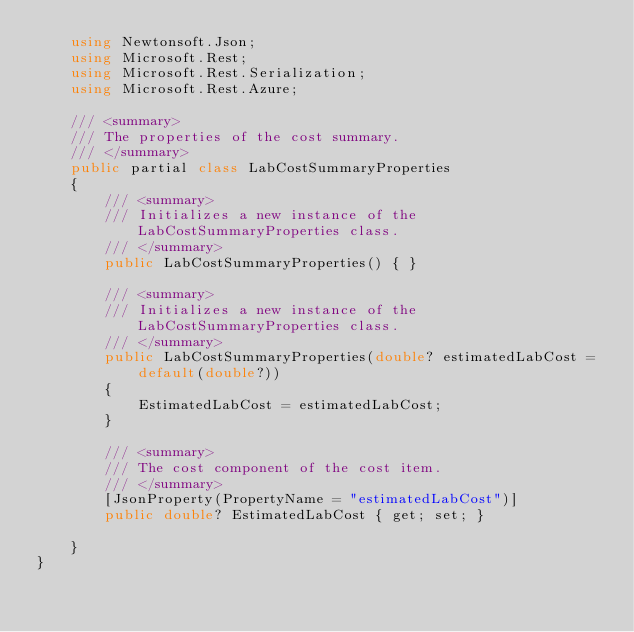<code> <loc_0><loc_0><loc_500><loc_500><_C#_>    using Newtonsoft.Json;
    using Microsoft.Rest;
    using Microsoft.Rest.Serialization;
    using Microsoft.Rest.Azure;

    /// <summary>
    /// The properties of the cost summary.
    /// </summary>
    public partial class LabCostSummaryProperties
    {
        /// <summary>
        /// Initializes a new instance of the LabCostSummaryProperties class.
        /// </summary>
        public LabCostSummaryProperties() { }

        /// <summary>
        /// Initializes a new instance of the LabCostSummaryProperties class.
        /// </summary>
        public LabCostSummaryProperties(double? estimatedLabCost = default(double?))
        {
            EstimatedLabCost = estimatedLabCost;
        }

        /// <summary>
        /// The cost component of the cost item.
        /// </summary>
        [JsonProperty(PropertyName = "estimatedLabCost")]
        public double? EstimatedLabCost { get; set; }

    }
}
</code> 